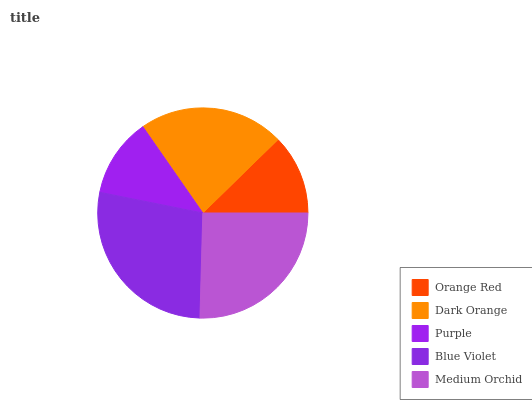Is Purple the minimum?
Answer yes or no. Yes. Is Blue Violet the maximum?
Answer yes or no. Yes. Is Dark Orange the minimum?
Answer yes or no. No. Is Dark Orange the maximum?
Answer yes or no. No. Is Dark Orange greater than Orange Red?
Answer yes or no. Yes. Is Orange Red less than Dark Orange?
Answer yes or no. Yes. Is Orange Red greater than Dark Orange?
Answer yes or no. No. Is Dark Orange less than Orange Red?
Answer yes or no. No. Is Dark Orange the high median?
Answer yes or no. Yes. Is Dark Orange the low median?
Answer yes or no. Yes. Is Medium Orchid the high median?
Answer yes or no. No. Is Orange Red the low median?
Answer yes or no. No. 